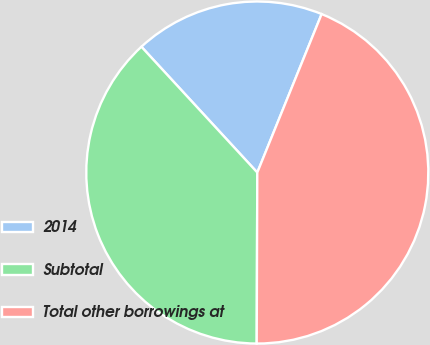Convert chart. <chart><loc_0><loc_0><loc_500><loc_500><pie_chart><fcel>2014<fcel>Subtotal<fcel>Total other borrowings at<nl><fcel>17.99%<fcel>38.1%<fcel>43.92%<nl></chart> 